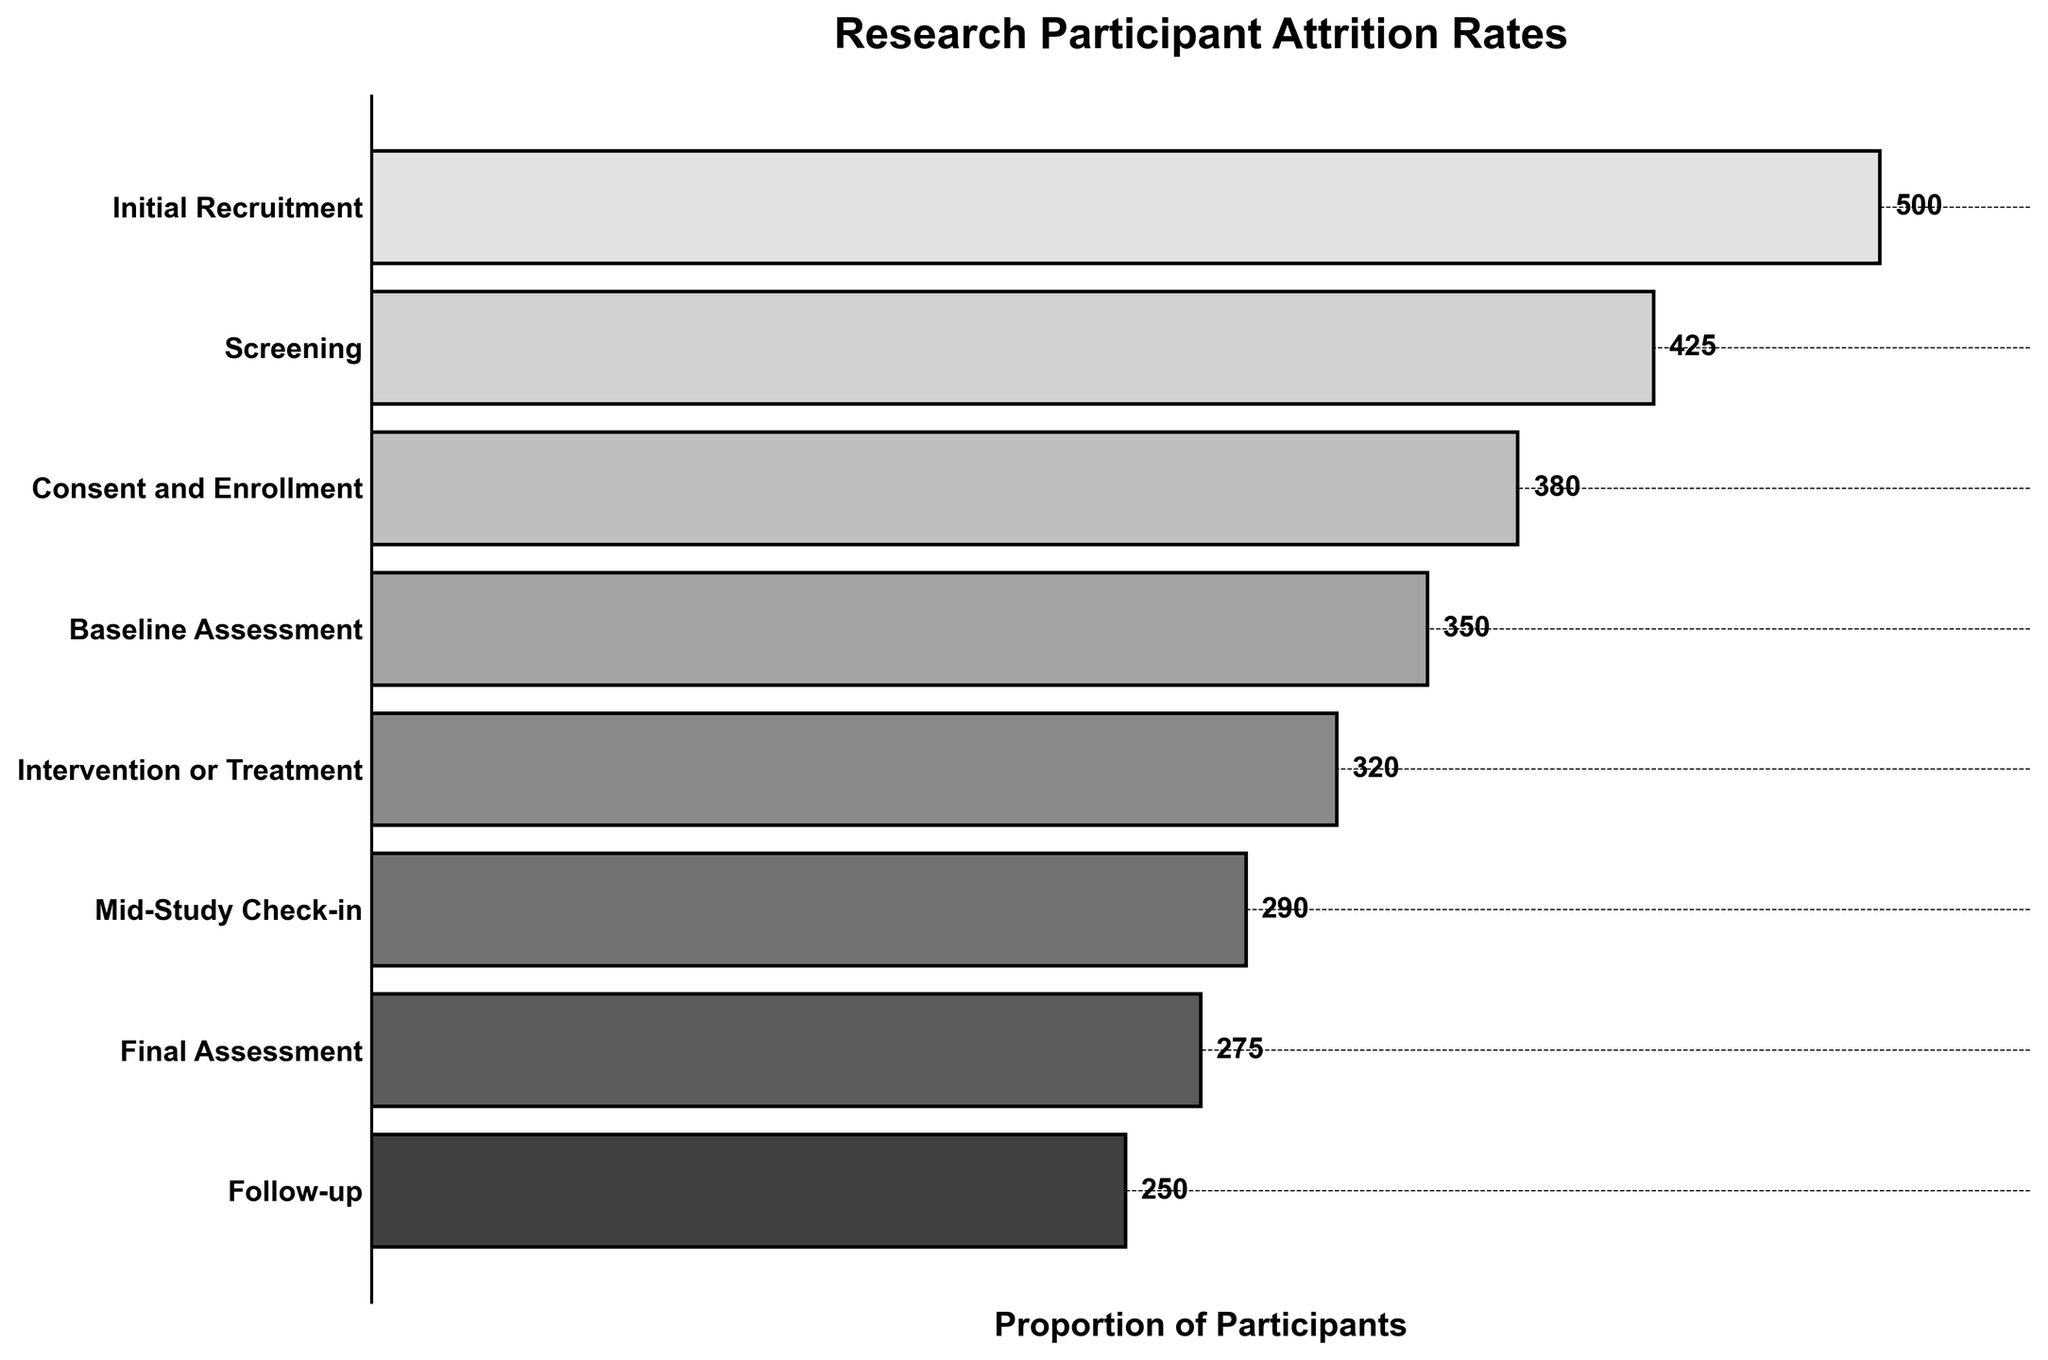What's the title of the chart? The title of the chart is clearly displayed at the top.
Answer: Research Participant Attrition Rates How many phases are displayed in the figure? The figure shows a bar for each phase, which can be counted visually from top to bottom.
Answer: 8 Which phase has the highest number of participants? The bar with the greatest width and the largest numerical label corresponds to the phase with the highest number of participants.
Answer: Initial Recruitment What is the difference in the number of participants between the Initial Recruitment and Final Assessment phases? Subtract the number of participants in the Final Assessment phase from those in the Initial Recruitment phase (500 - 275).
Answer: 225 Which phase has the least attrition of participants compared to the previous phase? Compare the numerical difference in participants between each consecutive phase; the smallest difference indicates the least attrition.
Answer: Final Assessment to Follow-up What proportion of participants remain at the Baseline Assessment phase relative to the Initial Recruitment phase? Calculate the proportion by dividing the number of participants in the Baseline Assessment phase by those in the Initial Recruitment phase (350 / 500).
Answer: 0.7 In which phase do we first observe fewer than 400 participants? Identify the first phase as you move down the chart where the number displayed is less than 400.
Answer: Consent and Enrollment What's the average number of participants in the last four phases? Sum the participants in the last four phases and divide by 4 ((320 + 290 + 275 + 250) / 4).
Answer: 283.75 Which phase experienced the greatest attrition rate in participants, and what is that rate? Calculate the percentage change in participants from one phase to the next for each phase. The greatest percentage decrease indicates the highest attrition rate. For example, from Initial Recruitment to Screening ((500 - 425) / 500). Identify the phase with the greatest rate.
Answer: Screening to Consent and Enrollment, 10.59% In which phase did we observe a drop to roughly half the number of participants compared to another earlier phase? Identify any phases where the number of participants is approximately half that of an earlier phase by visually inspecting the ratios and comparing the corresponding numerical labels, e.g., Final Assessment compared to the Initial Recruitment phase (275 ~ 0.55 * 500).
Answer: Final Assessment compared to Initial Recruitment 